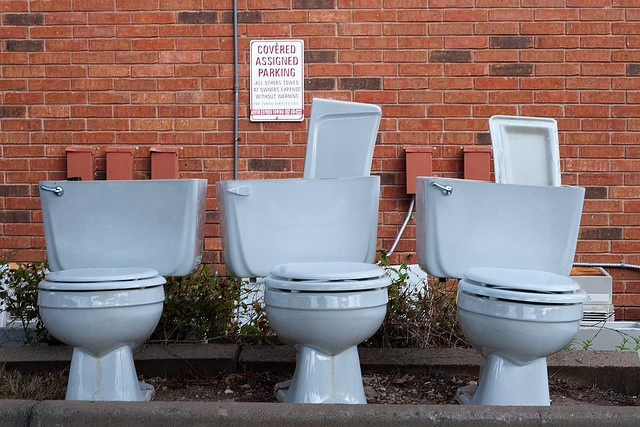Describe the objects in this image and their specific colors. I can see toilet in salmon, lightblue, darkgray, and gray tones, toilet in salmon, lightblue, lightgray, and darkgray tones, and toilet in salmon, darkgray, and gray tones in this image. 